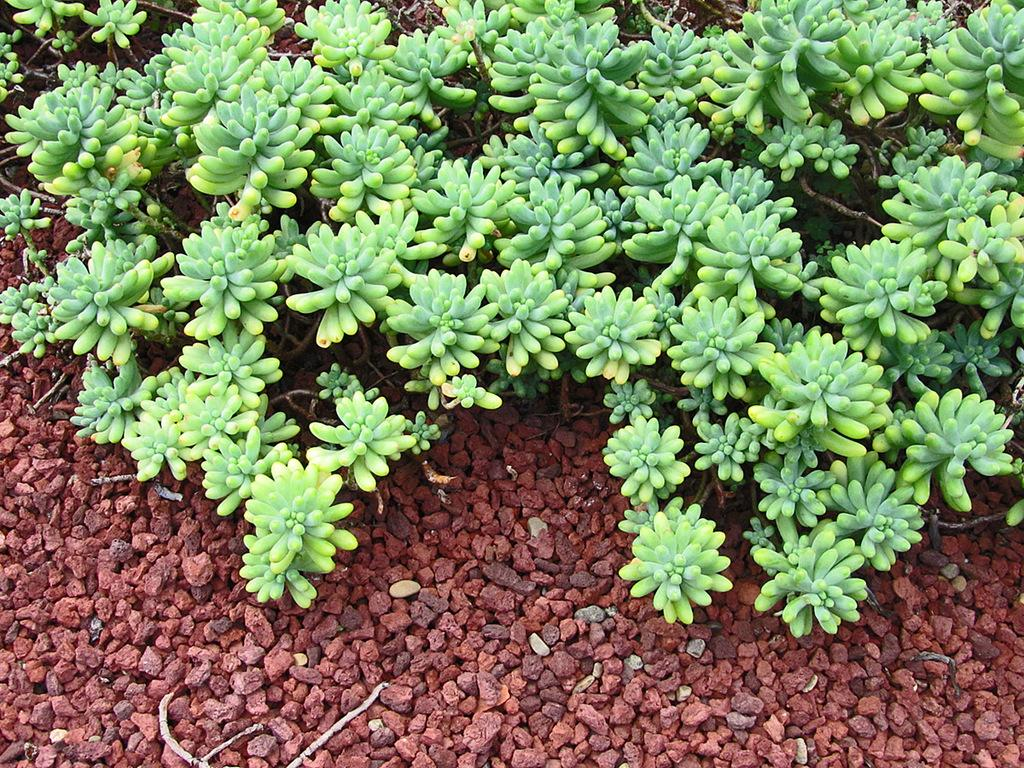What type of vegetation can be seen in the image? There are many plants in the image. Where are the plants located? The plants are on land. What type of terrain is present on the land? Sand and gravel are present on the land. Who is the manager of the event happening at night in the image? There is no event or nighttime scene depicted in the image, and therefore no manager is present. 